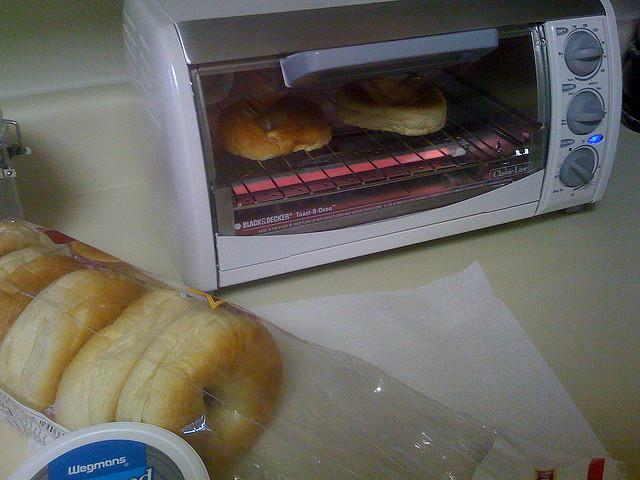Why is the bagel in there? toasting 